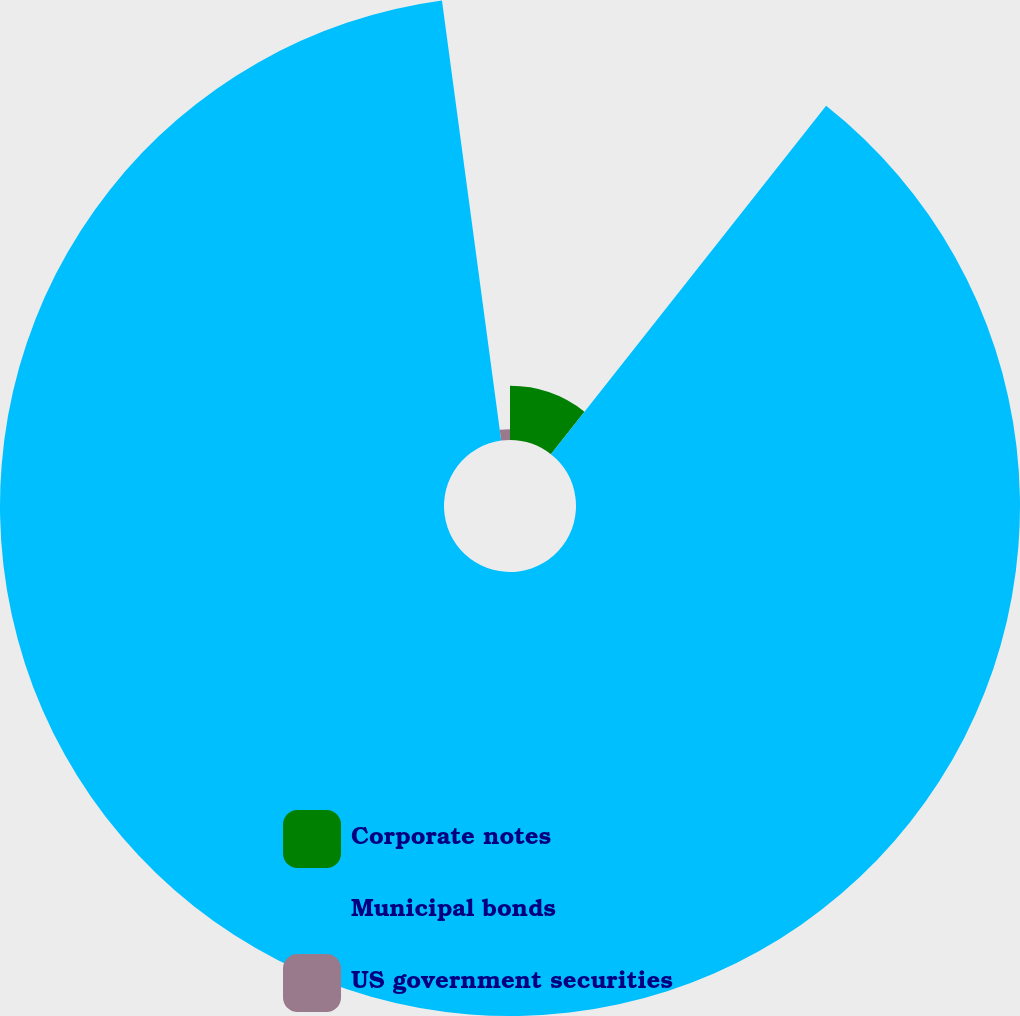<chart> <loc_0><loc_0><loc_500><loc_500><pie_chart><fcel>Corporate notes<fcel>Municipal bonds<fcel>US government securities<nl><fcel>10.64%<fcel>87.23%<fcel>2.13%<nl></chart> 